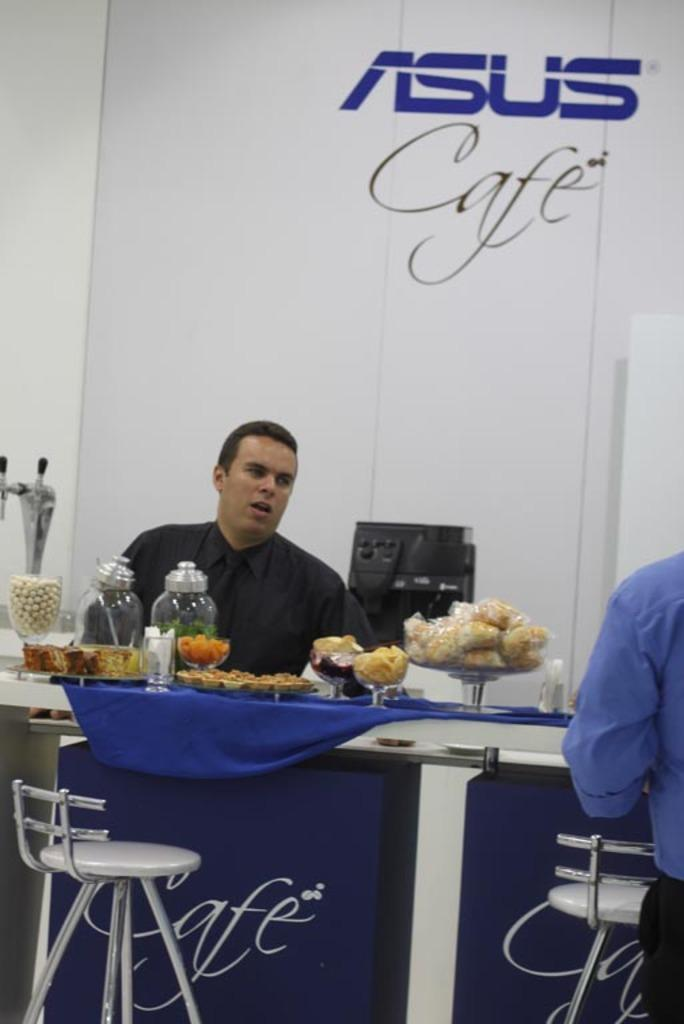What is the man in the image doing? The man is sitting in the image. What is the man sitting on? The man is sitting on a stool. Where is the man located in relation to the table? The man is in front of a table. What can be found on the table? There are objects on the table. What type of ink is the man using during the meeting in the image? There is no meeting or ink present in the image; it only shows a man sitting on a stool in front of a table with objects on it. 